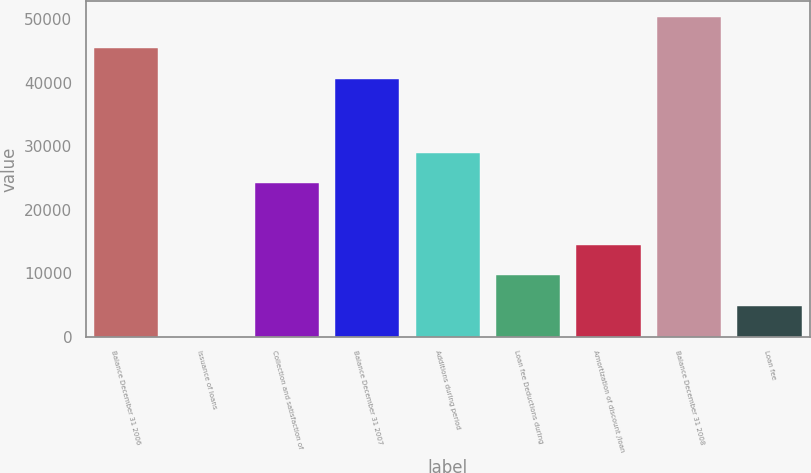Convert chart to OTSL. <chart><loc_0><loc_0><loc_500><loc_500><bar_chart><fcel>Balance December 31 2006<fcel>Issuance of loans<fcel>Collection and satisfaction of<fcel>Balance December 31 2007<fcel>Additions during period<fcel>Loan fee Deductions during<fcel>Amortization of discount /loan<fcel>Balance December 31 2008<fcel>Loan fee<nl><fcel>45470.8<fcel>8<fcel>24172<fcel>40638<fcel>29004.8<fcel>9673.6<fcel>14506.4<fcel>50303.6<fcel>4840.8<nl></chart> 